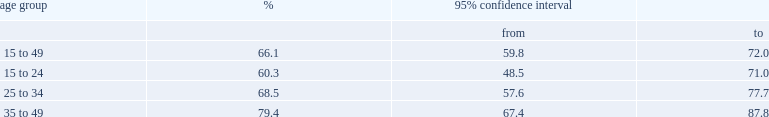Were women aged 15 to 24 less likely to take ocs containing 30 or more mcg of ee or were those aged 35 to 49? 15 to 24. Write the full table. {'header': ['age group', '%', '95% confidence interval', ''], 'rows': [['', '', 'from', 'to'], ['15 to 49', '66.1', '59.8', '72.0'], ['15 to 24', '60.3', '48.5', '71.0'], ['25 to 34', '68.5', '57.6', '77.7'], ['35 to 49', '79.4', '67.4', '87.8']]} 